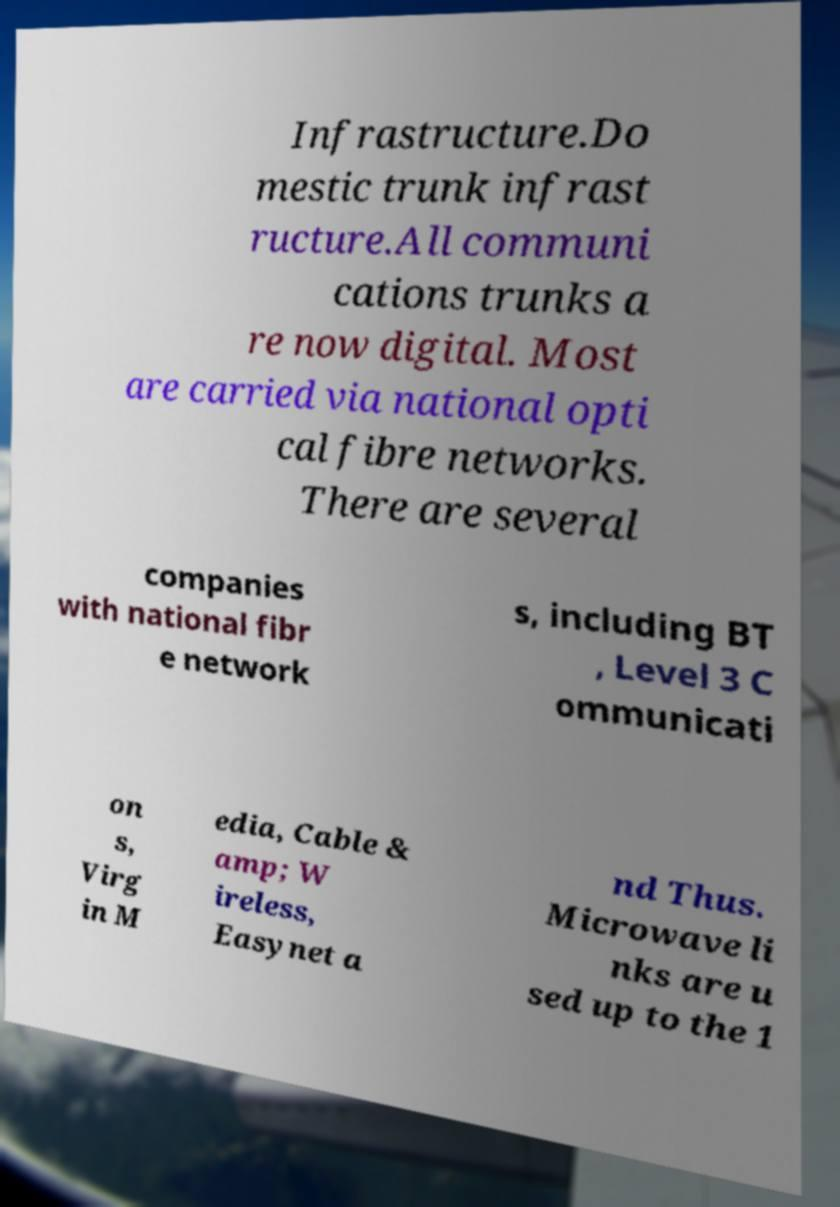Could you assist in decoding the text presented in this image and type it out clearly? Infrastructure.Do mestic trunk infrast ructure.All communi cations trunks a re now digital. Most are carried via national opti cal fibre networks. There are several companies with national fibr e network s, including BT , Level 3 C ommunicati on s, Virg in M edia, Cable & amp; W ireless, Easynet a nd Thus. Microwave li nks are u sed up to the 1 